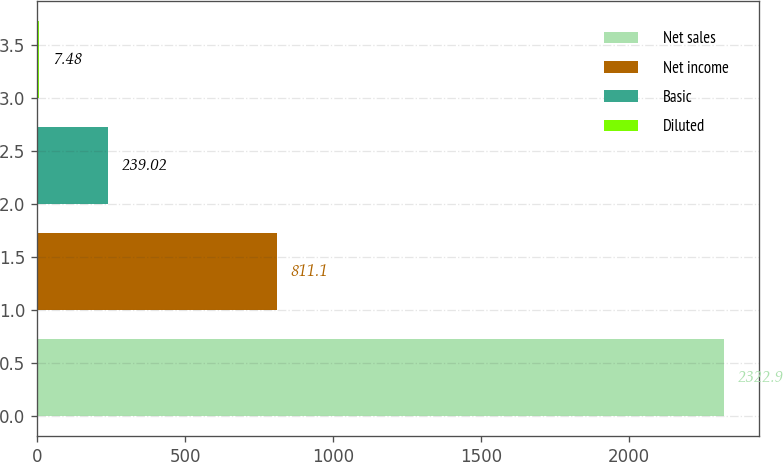<chart> <loc_0><loc_0><loc_500><loc_500><bar_chart><fcel>Net sales<fcel>Net income<fcel>Basic<fcel>Diluted<nl><fcel>2322.9<fcel>811.1<fcel>239.02<fcel>7.48<nl></chart> 